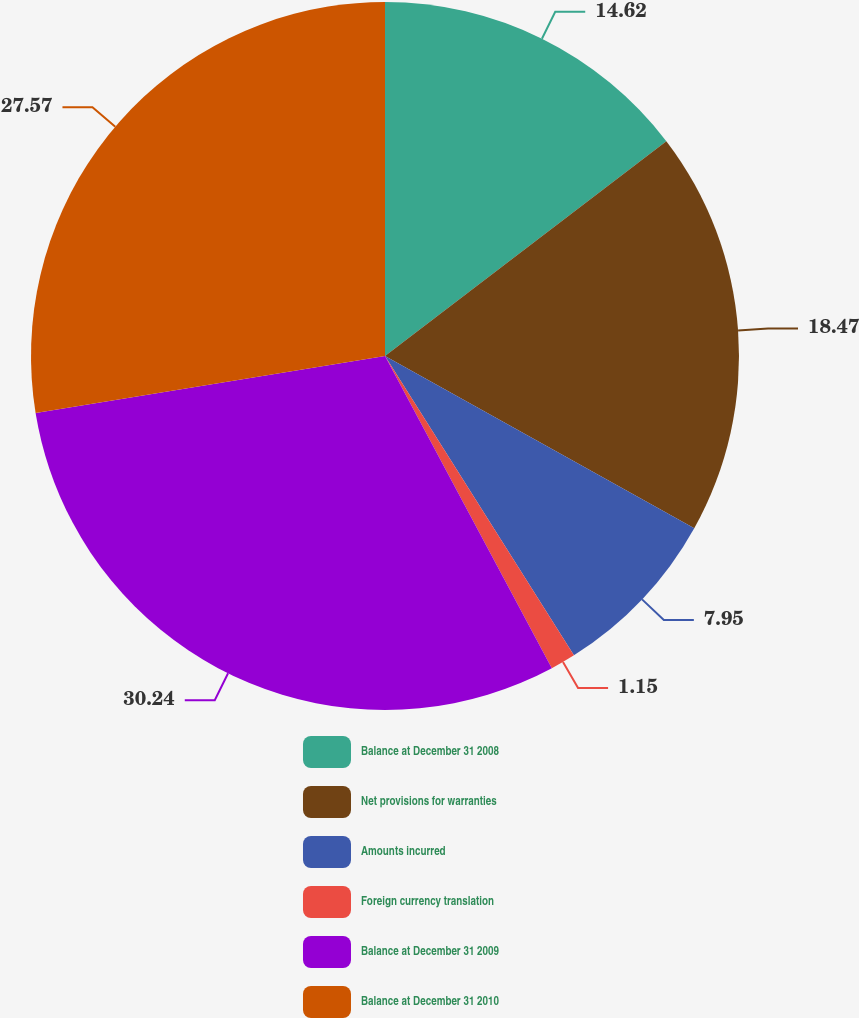Convert chart to OTSL. <chart><loc_0><loc_0><loc_500><loc_500><pie_chart><fcel>Balance at December 31 2008<fcel>Net provisions for warranties<fcel>Amounts incurred<fcel>Foreign currency translation<fcel>Balance at December 31 2009<fcel>Balance at December 31 2010<nl><fcel>14.62%<fcel>18.47%<fcel>7.95%<fcel>1.15%<fcel>30.24%<fcel>27.57%<nl></chart> 